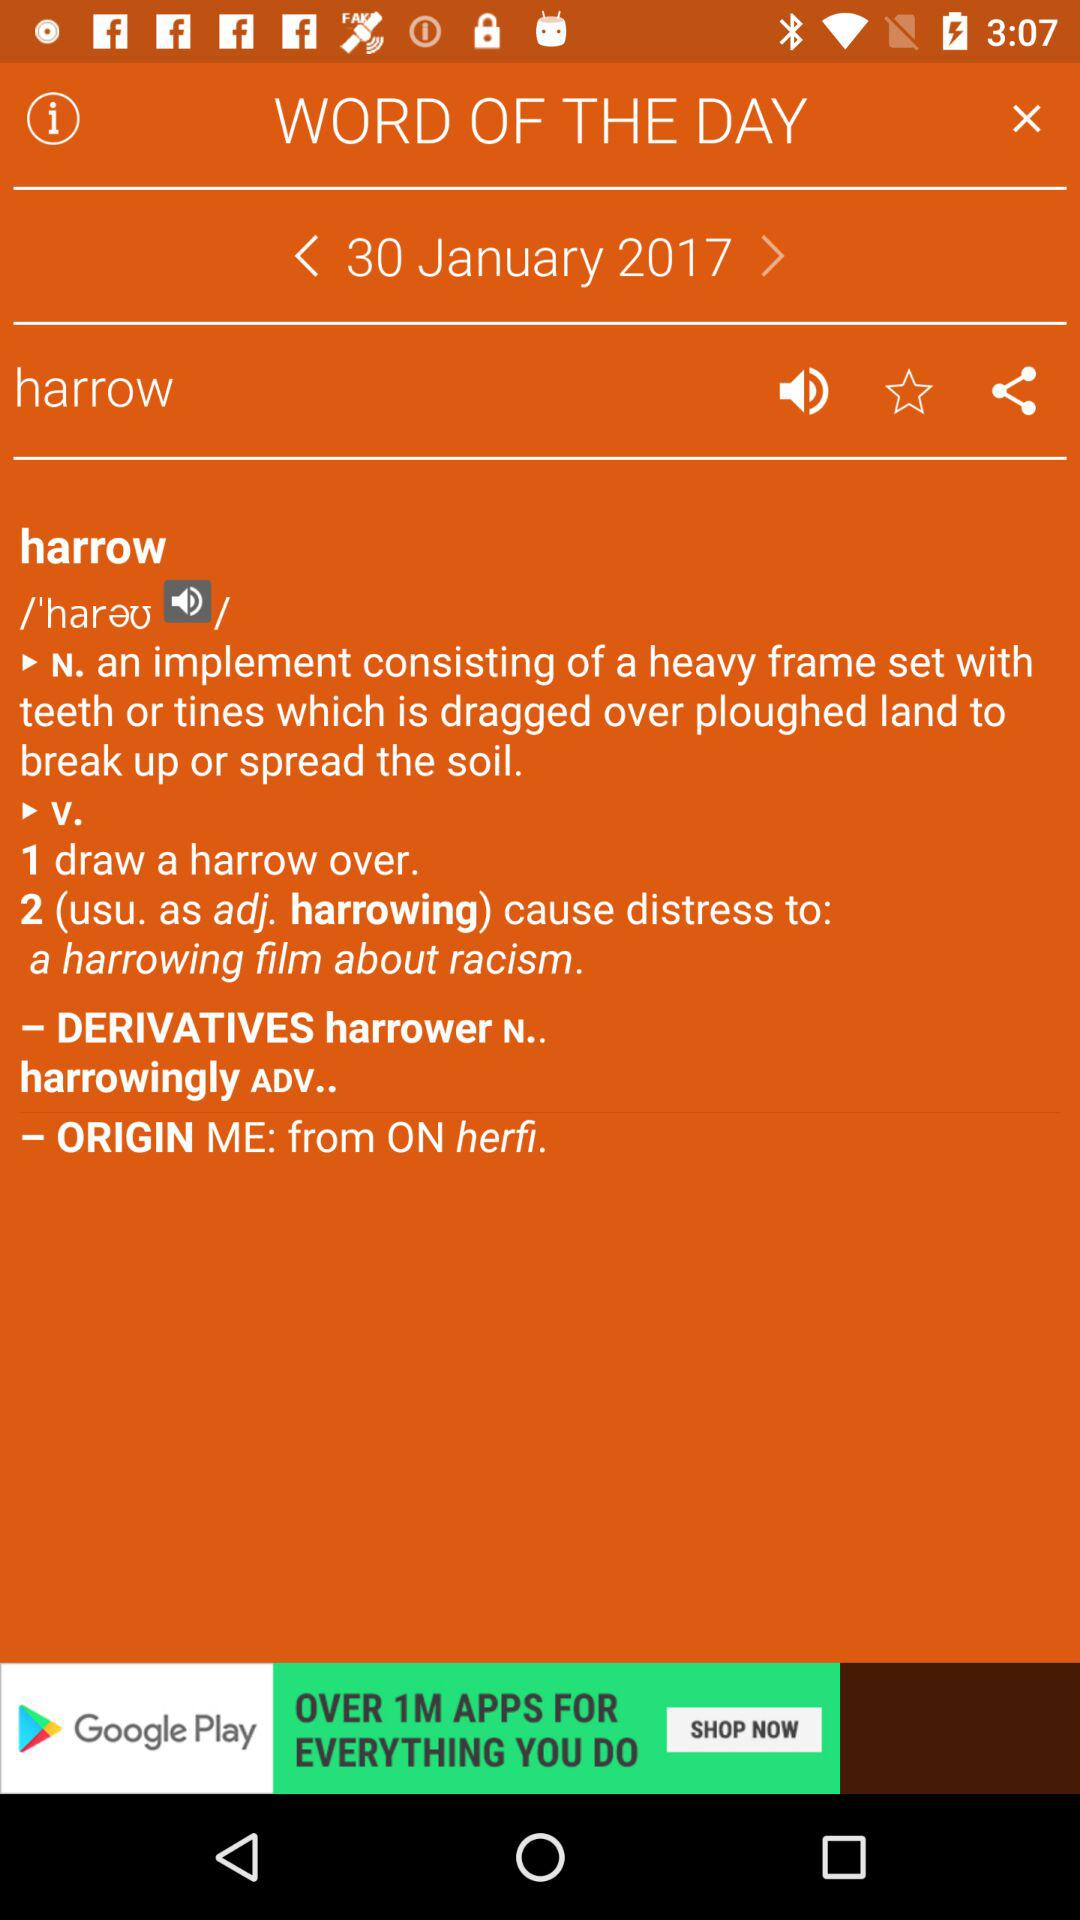What is the word of the day? The word of the day is "harrow". 